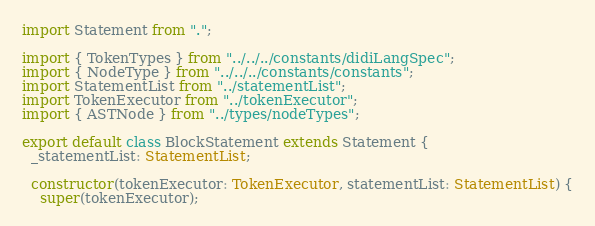<code> <loc_0><loc_0><loc_500><loc_500><_TypeScript_>import Statement from ".";

import { TokenTypes } from "../../../constants/didiLangSpec";
import { NodeType } from "../../../constants/constants";
import StatementList from "../statementList";
import TokenExecutor from "../tokenExecutor";
import { ASTNode } from "../types/nodeTypes";

export default class BlockStatement extends Statement {
  _statementList: StatementList;

  constructor(tokenExecutor: TokenExecutor, statementList: StatementList) {
    super(tokenExecutor);</code> 